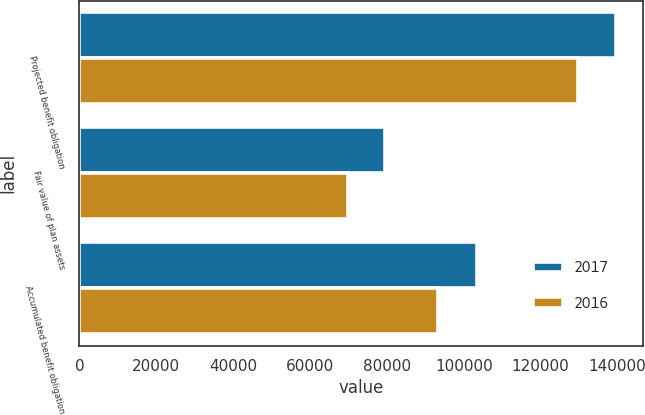Convert chart to OTSL. <chart><loc_0><loc_0><loc_500><loc_500><stacked_bar_chart><ecel><fcel>Projected benefit obligation<fcel>Fair value of plan assets<fcel>Accumulated benefit obligation<nl><fcel>2017<fcel>139516<fcel>79616<fcel>103470<nl><fcel>2016<fcel>129711<fcel>69823<fcel>93164<nl></chart> 